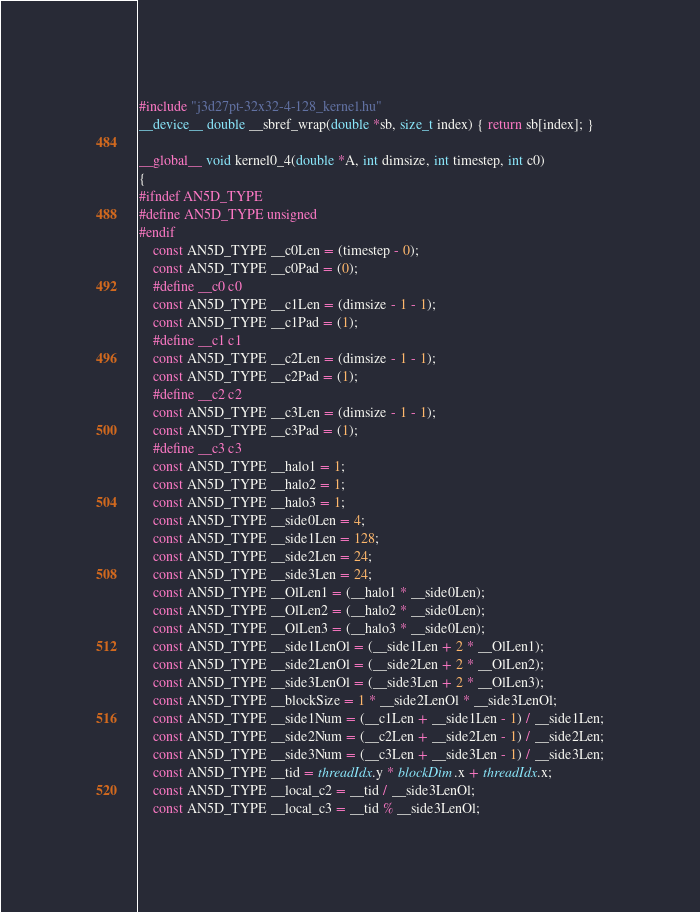<code> <loc_0><loc_0><loc_500><loc_500><_Cuda_>#include "j3d27pt-32x32-4-128_kernel.hu"
__device__ double __sbref_wrap(double *sb, size_t index) { return sb[index]; }

__global__ void kernel0_4(double *A, int dimsize, int timestep, int c0)
{
#ifndef AN5D_TYPE
#define AN5D_TYPE unsigned
#endif
    const AN5D_TYPE __c0Len = (timestep - 0);
    const AN5D_TYPE __c0Pad = (0);
    #define __c0 c0
    const AN5D_TYPE __c1Len = (dimsize - 1 - 1);
    const AN5D_TYPE __c1Pad = (1);
    #define __c1 c1
    const AN5D_TYPE __c2Len = (dimsize - 1 - 1);
    const AN5D_TYPE __c2Pad = (1);
    #define __c2 c2
    const AN5D_TYPE __c3Len = (dimsize - 1 - 1);
    const AN5D_TYPE __c3Pad = (1);
    #define __c3 c3
    const AN5D_TYPE __halo1 = 1;
    const AN5D_TYPE __halo2 = 1;
    const AN5D_TYPE __halo3 = 1;
    const AN5D_TYPE __side0Len = 4;
    const AN5D_TYPE __side1Len = 128;
    const AN5D_TYPE __side2Len = 24;
    const AN5D_TYPE __side3Len = 24;
    const AN5D_TYPE __OlLen1 = (__halo1 * __side0Len);
    const AN5D_TYPE __OlLen2 = (__halo2 * __side0Len);
    const AN5D_TYPE __OlLen3 = (__halo3 * __side0Len);
    const AN5D_TYPE __side1LenOl = (__side1Len + 2 * __OlLen1);
    const AN5D_TYPE __side2LenOl = (__side2Len + 2 * __OlLen2);
    const AN5D_TYPE __side3LenOl = (__side3Len + 2 * __OlLen3);
    const AN5D_TYPE __blockSize = 1 * __side2LenOl * __side3LenOl;
    const AN5D_TYPE __side1Num = (__c1Len + __side1Len - 1) / __side1Len;
    const AN5D_TYPE __side2Num = (__c2Len + __side2Len - 1) / __side2Len;
    const AN5D_TYPE __side3Num = (__c3Len + __side3Len - 1) / __side3Len;
    const AN5D_TYPE __tid = threadIdx.y * blockDim.x + threadIdx.x;
    const AN5D_TYPE __local_c2 = __tid / __side3LenOl;
    const AN5D_TYPE __local_c3 = __tid % __side3LenOl;</code> 